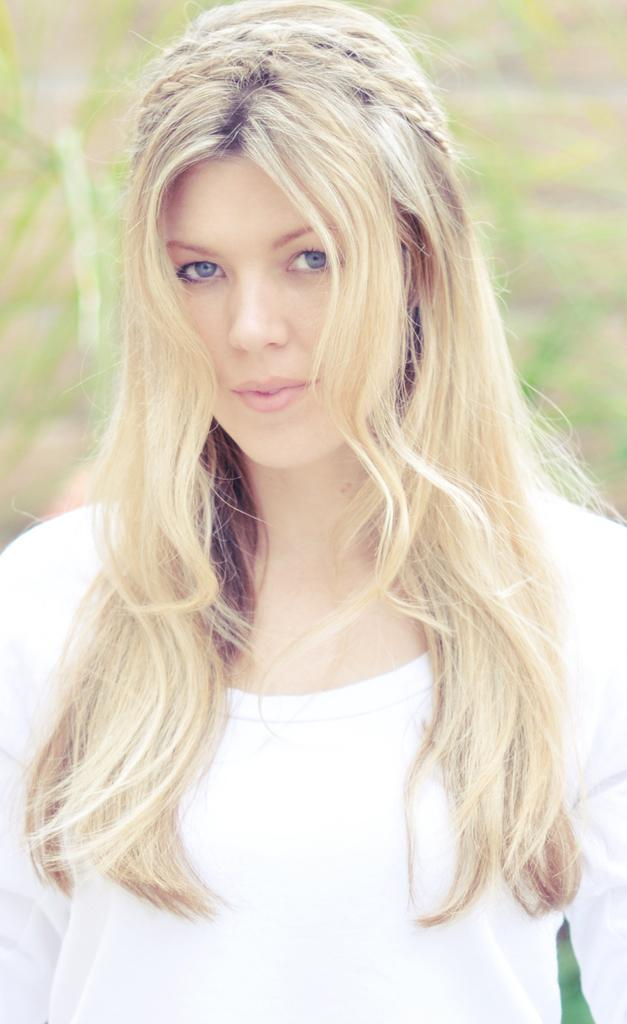What is the main subject of the image? The main subject of the image is a woman. What is the woman wearing in the image? The woman is wearing a white shirt. Can you describe the background of the image? The background of the image is blurry. What type of wave can be seen crashing on the shore in the image? There is no wave or shore present in the image; it features a woman wearing a white shirt with a blurry background. What type of engine is visible in the image? There is no engine present in the image. 